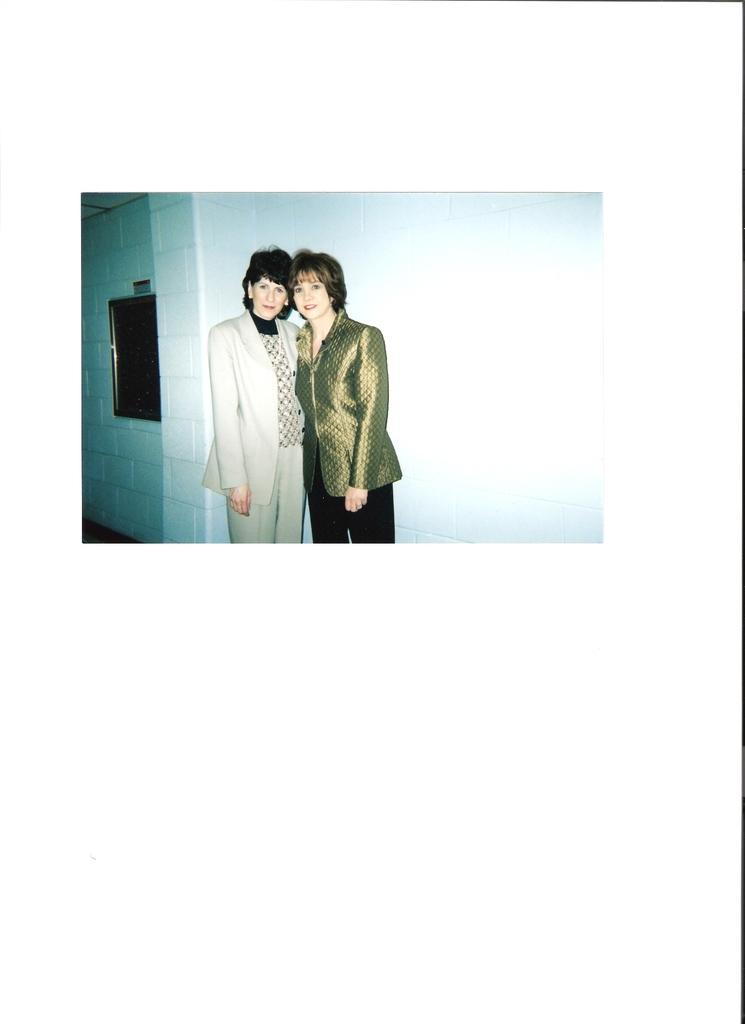How many women are in the image? There are two women in the image. What are the women wearing? The women are wearing blazers. What can be seen in the background of the image? There is a wall in the background of the image. Is there any indication of natural light in the image? There appears to be a window on the left side of the image, which suggests natural light might be present. What type of trick are the women performing in the image? There is no indication of a trick being performed in the image; the women are simply standing and wearing blazers. 